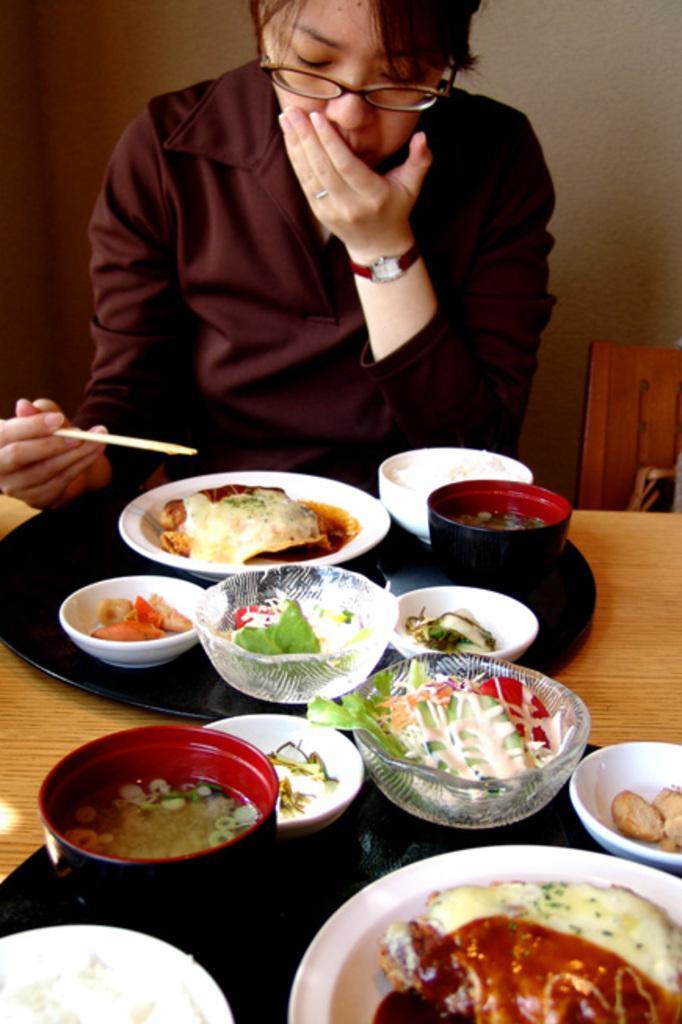How would you summarize this image in a sentence or two? This woman is sitting on a chair and holding chopsticks. On this table there are bowls, plate and food. 